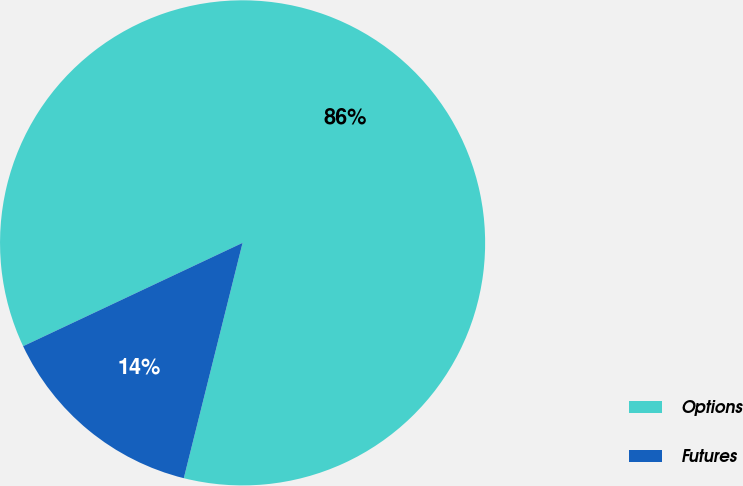Convert chart. <chart><loc_0><loc_0><loc_500><loc_500><pie_chart><fcel>Options<fcel>Futures<nl><fcel>85.9%<fcel>14.1%<nl></chart> 